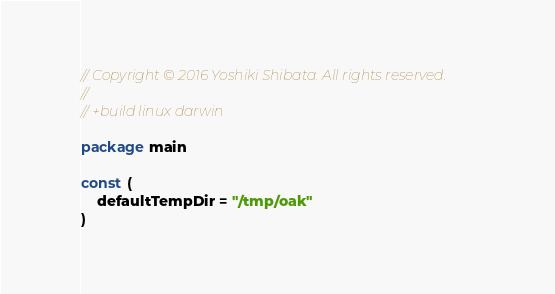Convert code to text. <code><loc_0><loc_0><loc_500><loc_500><_Go_>// Copyright © 2016 Yoshiki Shibata. All rights reserved.
//
// +build linux darwin

package main

const (
	defaultTempDir = "/tmp/oak"
)
</code> 